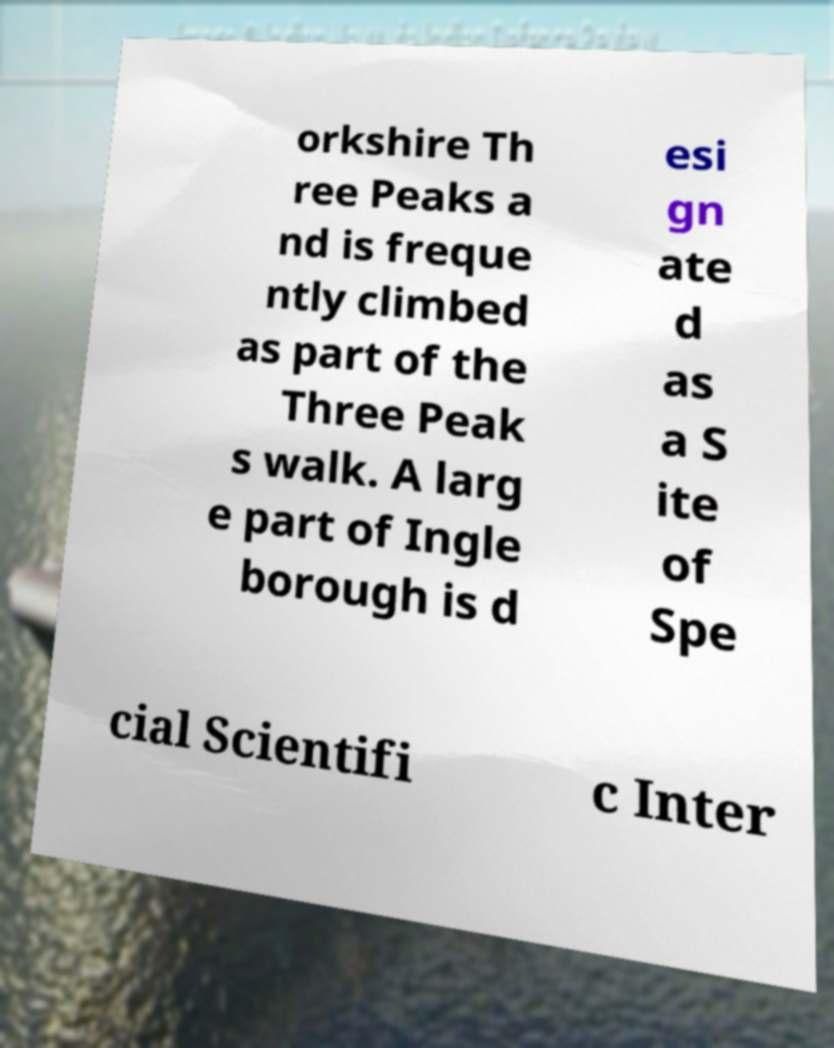What messages or text are displayed in this image? I need them in a readable, typed format. orkshire Th ree Peaks a nd is freque ntly climbed as part of the Three Peak s walk. A larg e part of Ingle borough is d esi gn ate d as a S ite of Spe cial Scientifi c Inter 